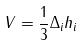Convert formula to latex. <formula><loc_0><loc_0><loc_500><loc_500>V = \frac { 1 } { 3 } \Delta _ { i } h _ { i }</formula> 